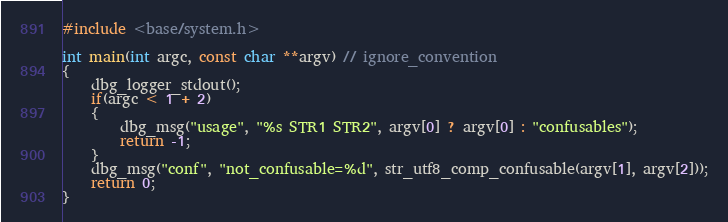<code> <loc_0><loc_0><loc_500><loc_500><_C++_>#include <base/system.h>

int main(int argc, const char **argv) // ignore_convention
{
	dbg_logger_stdout();
	if(argc < 1 + 2)
	{
		dbg_msg("usage", "%s STR1 STR2", argv[0] ? argv[0] : "confusables");
		return -1;
	}
	dbg_msg("conf", "not_confusable=%d", str_utf8_comp_confusable(argv[1], argv[2]));
	return 0;
}</code> 